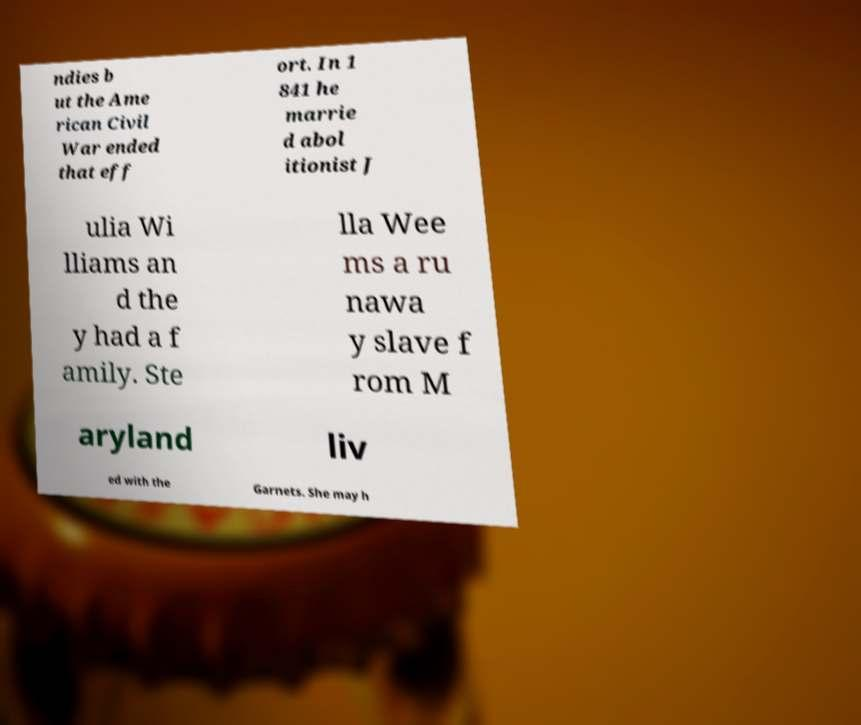What messages or text are displayed in this image? I need them in a readable, typed format. ndies b ut the Ame rican Civil War ended that eff ort. In 1 841 he marrie d abol itionist J ulia Wi lliams an d the y had a f amily. Ste lla Wee ms a ru nawa y slave f rom M aryland liv ed with the Garnets. She may h 